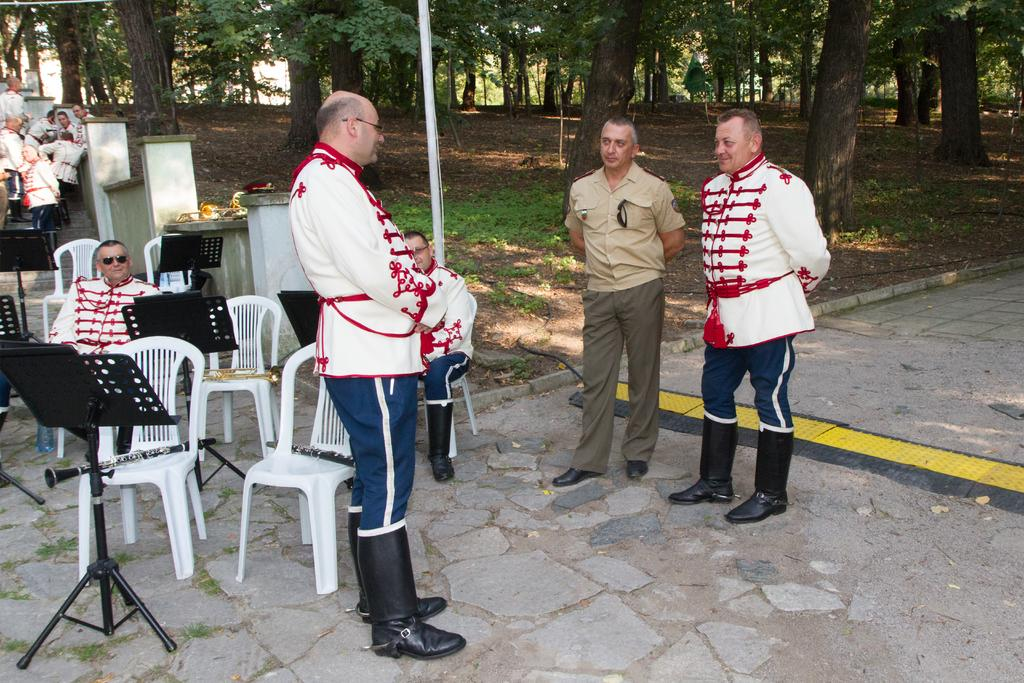How many people are sitting in the image? There are two persons sitting on chairs in the image. What are the people on the ground doing? The people standing on the ground are not specified in the facts, so we cannot determine their actions. What architectural feature is present in the image? There is a staircase in the image. What type of vegetation can be seen in the image? There are trees in the image. What type of cake is being served on the staircase in the image? There is no cake present in the image; it only features two persons sitting on chairs, people standing on the ground, a staircase, and trees. 